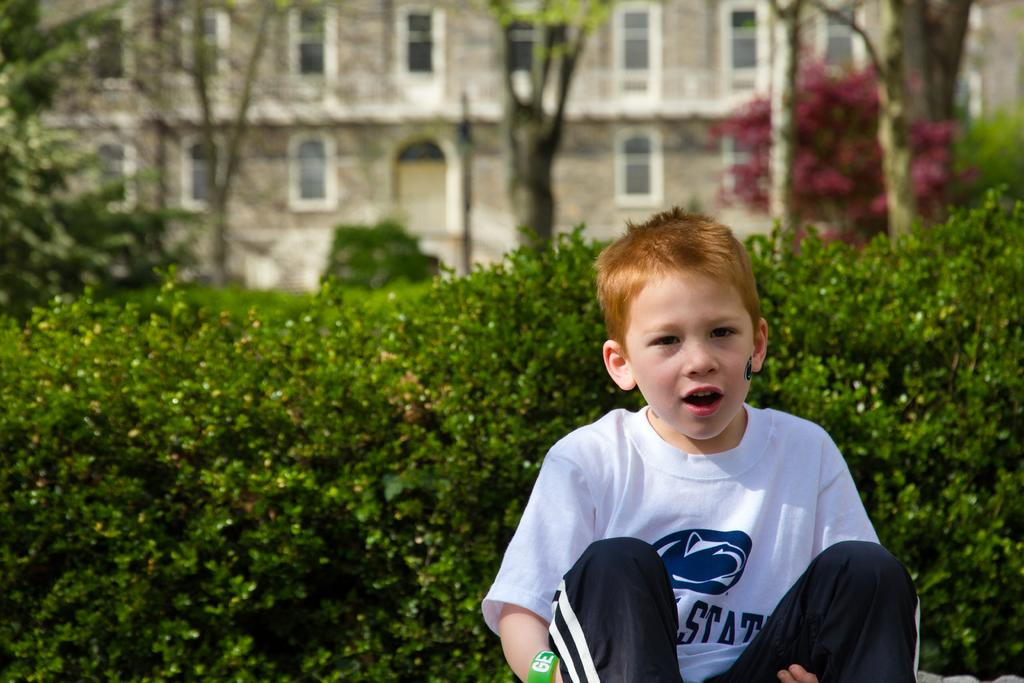Provide a one-sentence caption for the provided image. A boy in a white and blue shirt that is displaying the word Stat. 